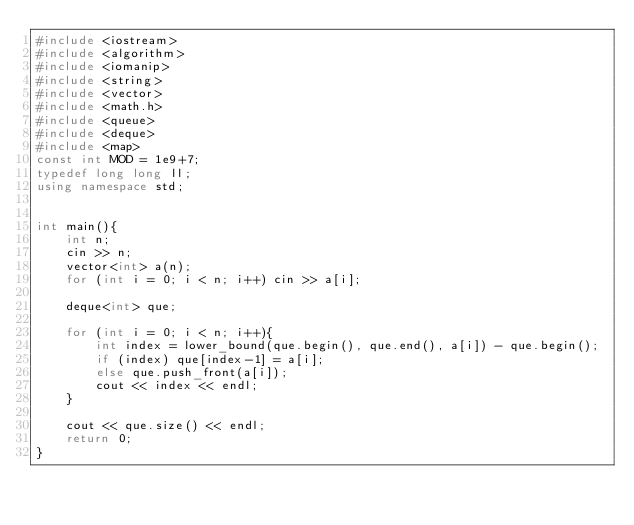Convert code to text. <code><loc_0><loc_0><loc_500><loc_500><_C++_>#include <iostream>
#include <algorithm>
#include <iomanip>
#include <string>
#include <vector>
#include <math.h>
#include <queue>
#include <deque>
#include <map>
const int MOD = 1e9+7;
typedef long long ll;
using namespace std;


int main(){
	int n;
	cin >> n;
	vector<int> a(n);
	for (int i = 0; i < n; i++) cin >> a[i];

	deque<int> que;

	for (int i = 0; i < n; i++){
		int index = lower_bound(que.begin(), que.end(), a[i]) - que.begin();
		if (index) que[index-1] = a[i];
		else que.push_front(a[i]);
		cout << index << endl;
	}

	cout << que.size() << endl;
	return 0;
}</code> 